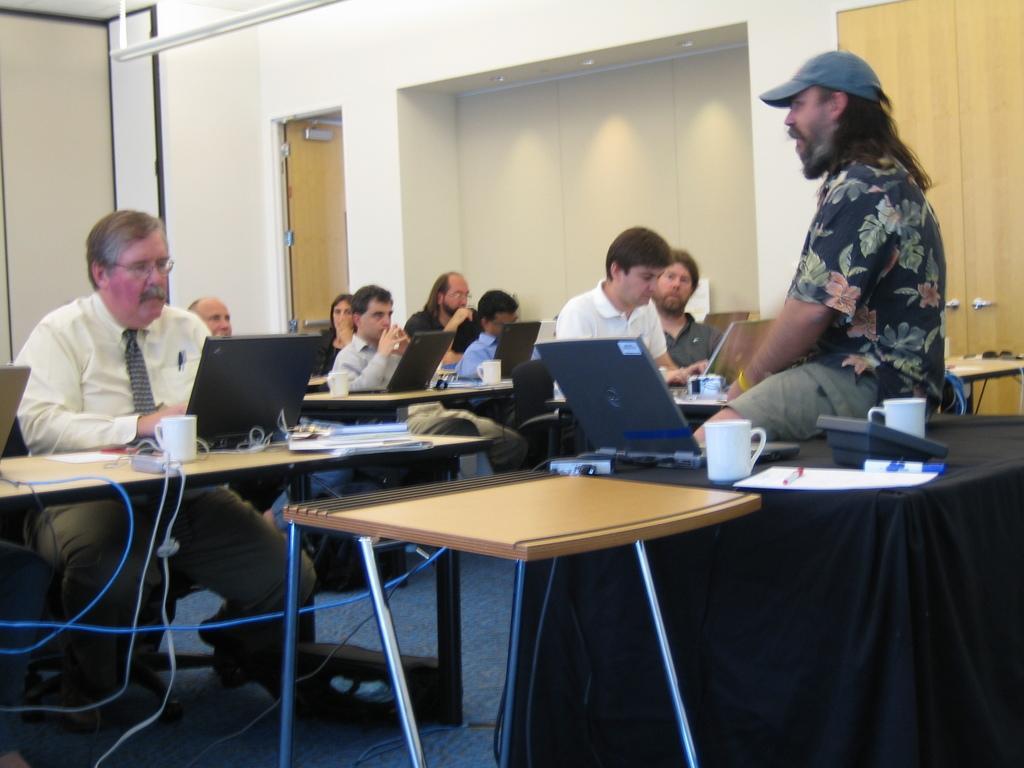Could you give a brief overview of what you see in this image? In this image there are group of people sitting in chairs , and on table there are glasses, papers, laptops, and in the back ground there is another person sitting on a table near a laptop , door, lights, wall. 